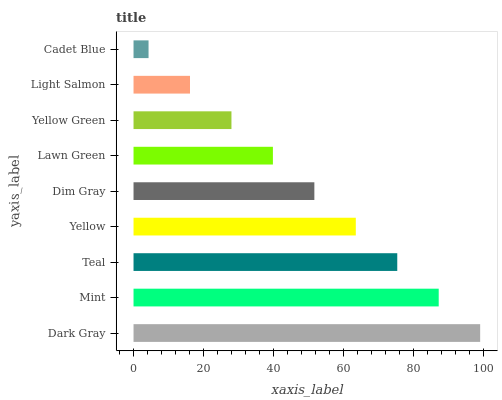Is Cadet Blue the minimum?
Answer yes or no. Yes. Is Dark Gray the maximum?
Answer yes or no. Yes. Is Mint the minimum?
Answer yes or no. No. Is Mint the maximum?
Answer yes or no. No. Is Dark Gray greater than Mint?
Answer yes or no. Yes. Is Mint less than Dark Gray?
Answer yes or no. Yes. Is Mint greater than Dark Gray?
Answer yes or no. No. Is Dark Gray less than Mint?
Answer yes or no. No. Is Dim Gray the high median?
Answer yes or no. Yes. Is Dim Gray the low median?
Answer yes or no. Yes. Is Teal the high median?
Answer yes or no. No. Is Yellow the low median?
Answer yes or no. No. 